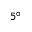<formula> <loc_0><loc_0><loc_500><loc_500>5 ^ { \circ }</formula> 